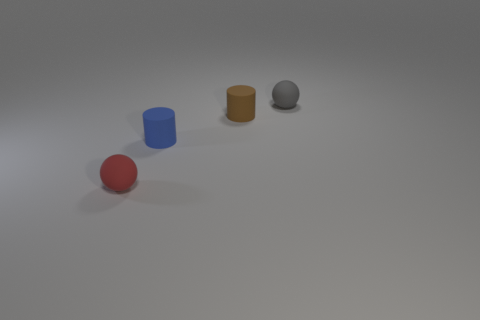Does the rubber sphere behind the brown matte object have the same size as the tiny blue cylinder?
Offer a terse response. Yes. How many things are rubber spheres on the right side of the brown matte cylinder or tiny balls that are right of the small blue thing?
Your response must be concise. 1. What number of rubber objects are brown objects or red objects?
Your answer should be compact. 2. What shape is the gray thing?
Your answer should be compact. Sphere. Is the material of the tiny brown object the same as the small blue cylinder?
Make the answer very short. Yes. Are there any blue cylinders right of the small matte sphere that is to the right of the ball that is on the left side of the blue rubber object?
Your response must be concise. No. What is the shape of the small rubber thing that is behind the tiny red rubber thing and on the left side of the brown rubber cylinder?
Ensure brevity in your answer.  Cylinder. What color is the tiny ball that is to the right of the matte sphere in front of the tiny sphere on the right side of the tiny brown matte object?
Your response must be concise. Gray. Is the number of blue matte cylinders right of the brown matte cylinder greater than the number of tiny brown cylinders that are in front of the blue cylinder?
Keep it short and to the point. No. What number of other objects are the same size as the red ball?
Keep it short and to the point. 3. 